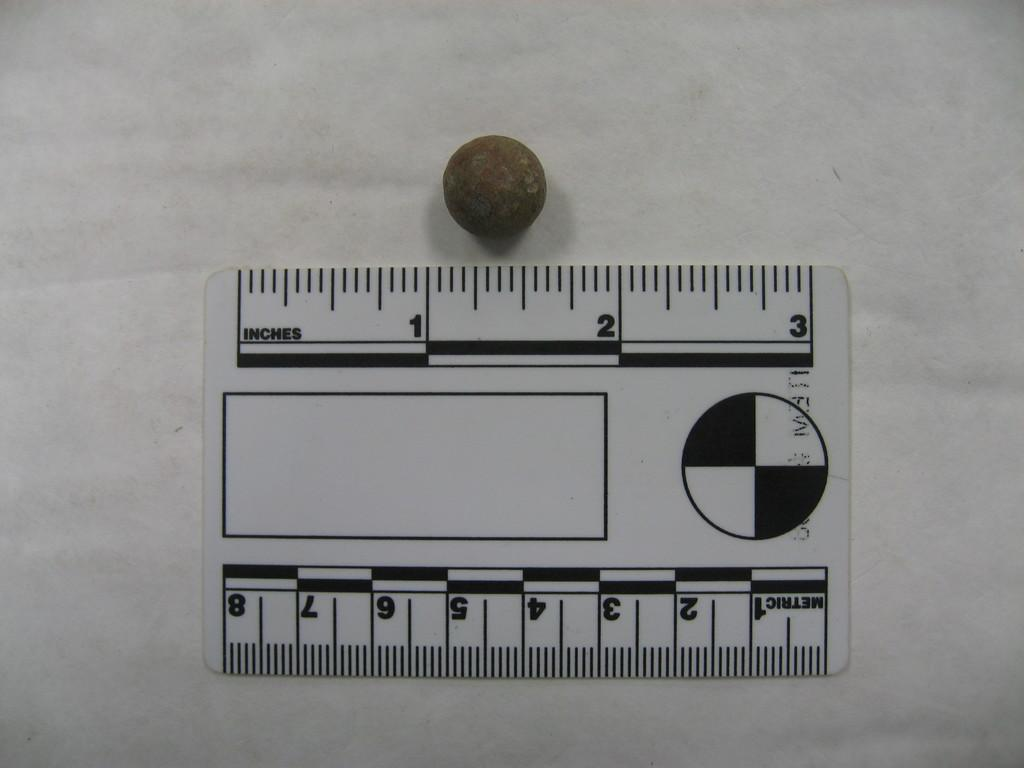<image>
Write a terse but informative summary of the picture. Small ruler that says "Metric" on it measuring a bean. 